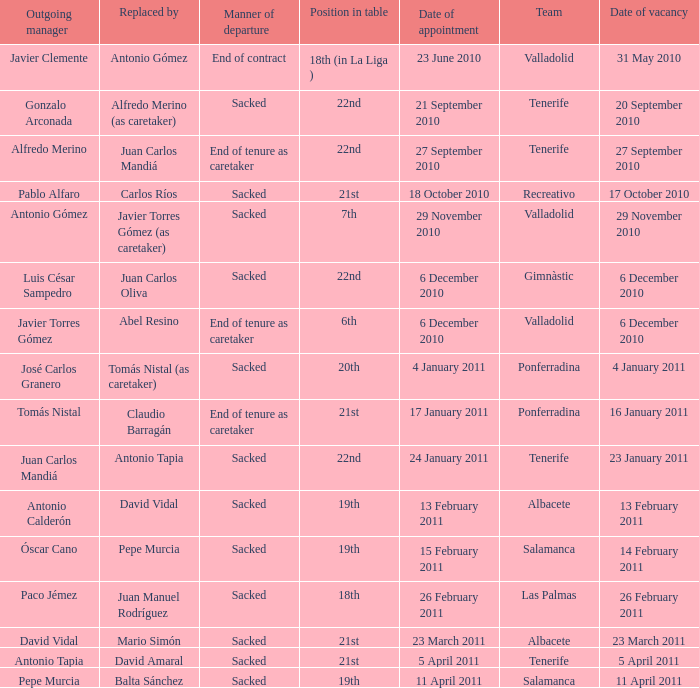What was the appointment date for outgoing manager luis césar sampedro 6 December 2010. 